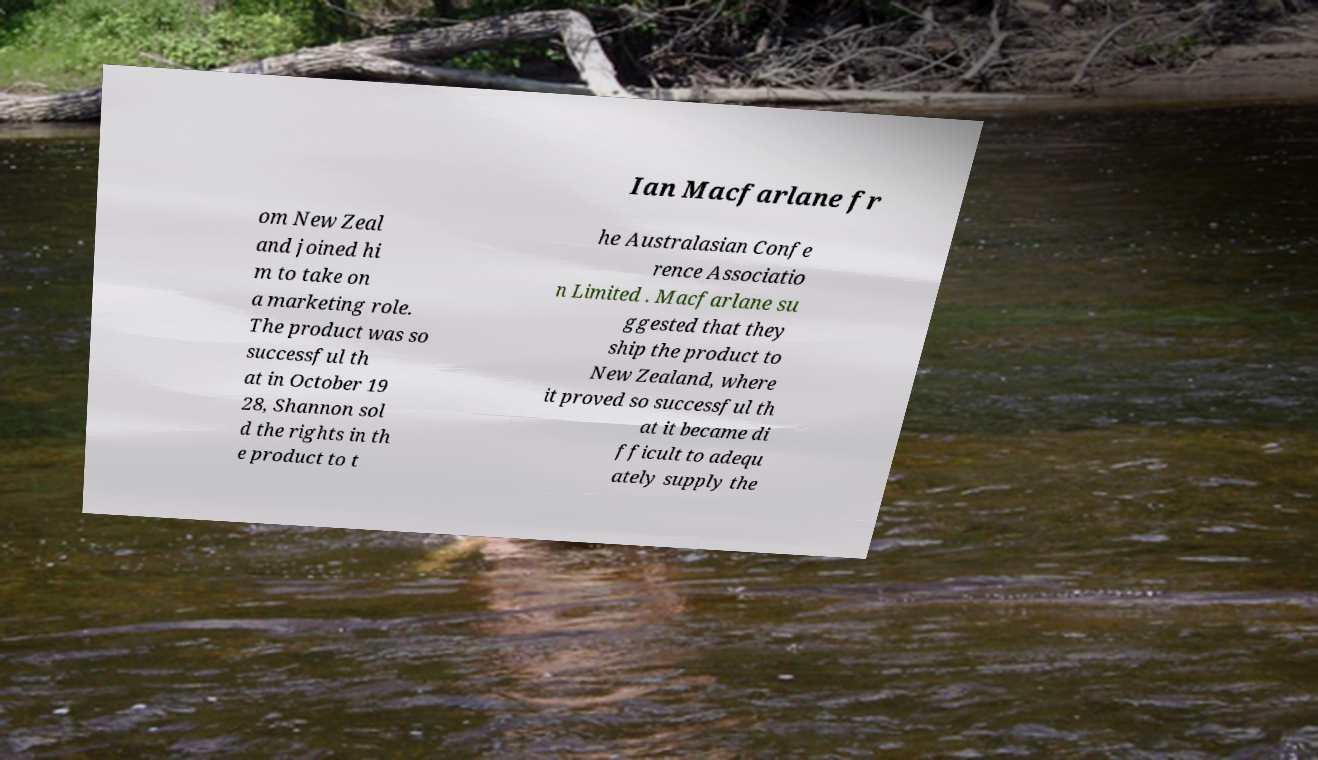Can you accurately transcribe the text from the provided image for me? Ian Macfarlane fr om New Zeal and joined hi m to take on a marketing role. The product was so successful th at in October 19 28, Shannon sol d the rights in th e product to t he Australasian Confe rence Associatio n Limited . Macfarlane su ggested that they ship the product to New Zealand, where it proved so successful th at it became di fficult to adequ ately supply the 